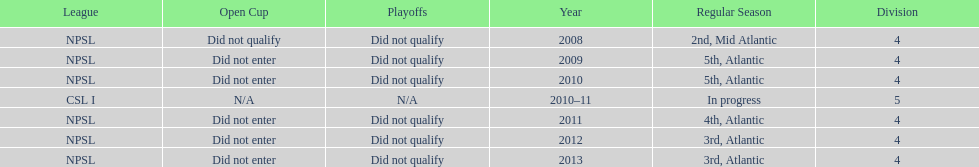Help me parse the entirety of this table. {'header': ['League', 'Open Cup', 'Playoffs', 'Year', 'Regular Season', 'Division'], 'rows': [['NPSL', 'Did not qualify', 'Did not qualify', '2008', '2nd, Mid Atlantic', '4'], ['NPSL', 'Did not enter', 'Did not qualify', '2009', '5th, Atlantic', '4'], ['NPSL', 'Did not enter', 'Did not qualify', '2010', '5th, Atlantic', '4'], ['CSL I', 'N/A', 'N/A', '2010–11', 'In progress', '5'], ['NPSL', 'Did not enter', 'Did not qualify', '2011', '4th, Atlantic', '4'], ['NPSL', 'Did not enter', 'Did not qualify', '2012', '3rd, Atlantic', '4'], ['NPSL', 'Did not enter', 'Did not qualify', '2013', '3rd, Atlantic', '4']]} In what year only did they compete in division 5 2010-11. 